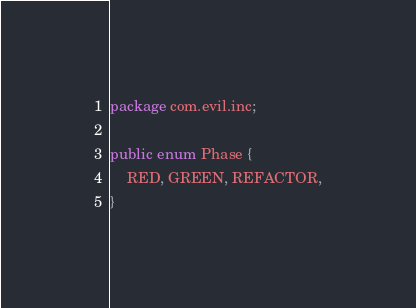Convert code to text. <code><loc_0><loc_0><loc_500><loc_500><_Java_>package com.evil.inc;

public enum Phase {
    RED, GREEN, REFACTOR,
}
</code> 